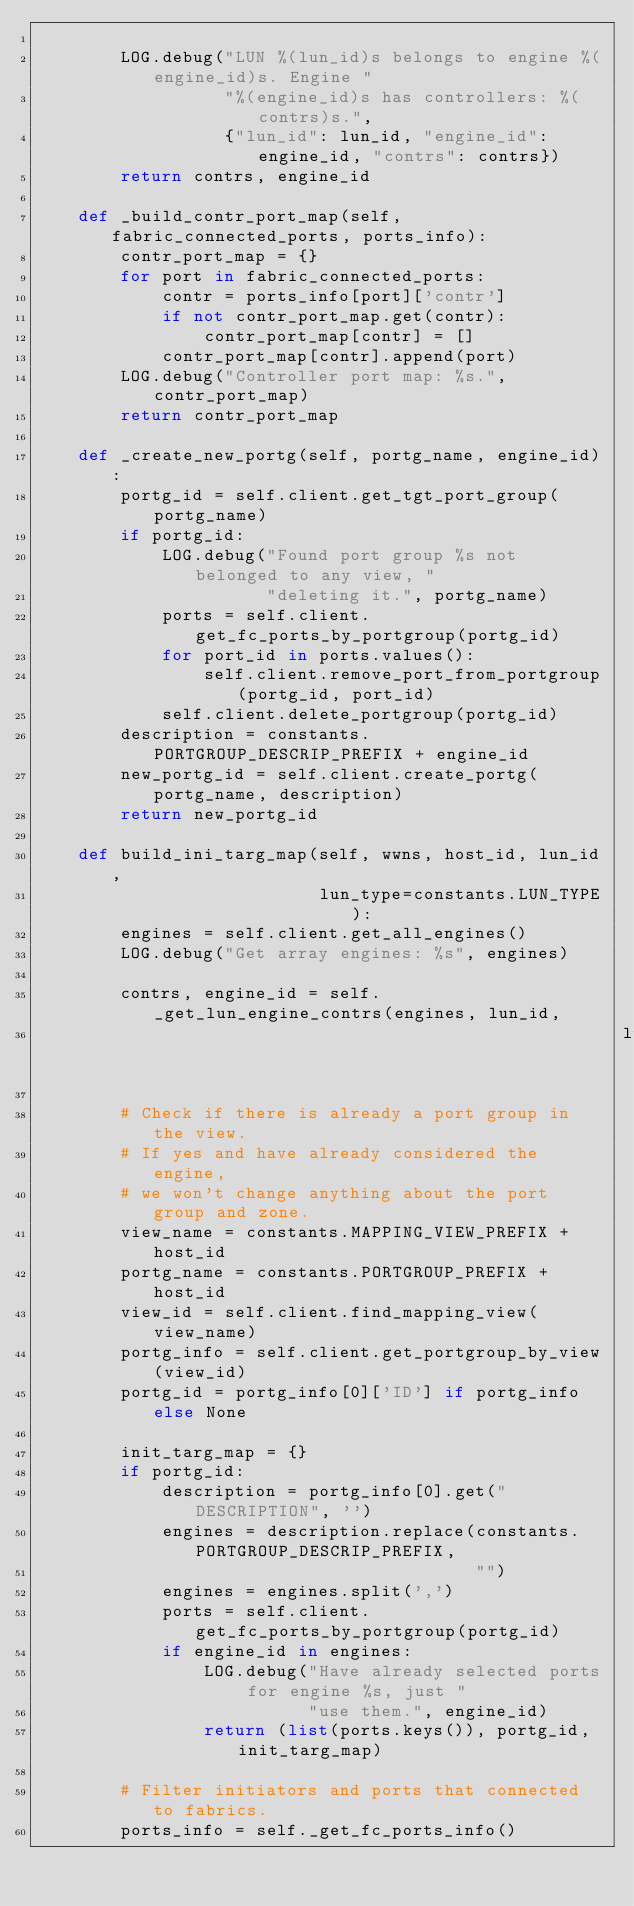Convert code to text. <code><loc_0><loc_0><loc_500><loc_500><_Python_>
        LOG.debug("LUN %(lun_id)s belongs to engine %(engine_id)s. Engine "
                  "%(engine_id)s has controllers: %(contrs)s.",
                  {"lun_id": lun_id, "engine_id": engine_id, "contrs": contrs})
        return contrs, engine_id

    def _build_contr_port_map(self, fabric_connected_ports, ports_info):
        contr_port_map = {}
        for port in fabric_connected_ports:
            contr = ports_info[port]['contr']
            if not contr_port_map.get(contr):
                contr_port_map[contr] = []
            contr_port_map[contr].append(port)
        LOG.debug("Controller port map: %s.", contr_port_map)
        return contr_port_map

    def _create_new_portg(self, portg_name, engine_id):
        portg_id = self.client.get_tgt_port_group(portg_name)
        if portg_id:
            LOG.debug("Found port group %s not belonged to any view, "
                      "deleting it.", portg_name)
            ports = self.client.get_fc_ports_by_portgroup(portg_id)
            for port_id in ports.values():
                self.client.remove_port_from_portgroup(portg_id, port_id)
            self.client.delete_portgroup(portg_id)
        description = constants.PORTGROUP_DESCRIP_PREFIX + engine_id
        new_portg_id = self.client.create_portg(portg_name, description)
        return new_portg_id

    def build_ini_targ_map(self, wwns, host_id, lun_id,
                           lun_type=constants.LUN_TYPE):
        engines = self.client.get_all_engines()
        LOG.debug("Get array engines: %s", engines)

        contrs, engine_id = self._get_lun_engine_contrs(engines, lun_id,
                                                        lun_type)

        # Check if there is already a port group in the view.
        # If yes and have already considered the engine,
        # we won't change anything about the port group and zone.
        view_name = constants.MAPPING_VIEW_PREFIX + host_id
        portg_name = constants.PORTGROUP_PREFIX + host_id
        view_id = self.client.find_mapping_view(view_name)
        portg_info = self.client.get_portgroup_by_view(view_id)
        portg_id = portg_info[0]['ID'] if portg_info else None

        init_targ_map = {}
        if portg_id:
            description = portg_info[0].get("DESCRIPTION", '')
            engines = description.replace(constants.PORTGROUP_DESCRIP_PREFIX,
                                          "")
            engines = engines.split(',')
            ports = self.client.get_fc_ports_by_portgroup(portg_id)
            if engine_id in engines:
                LOG.debug("Have already selected ports for engine %s, just "
                          "use them.", engine_id)
                return (list(ports.keys()), portg_id, init_targ_map)

        # Filter initiators and ports that connected to fabrics.
        ports_info = self._get_fc_ports_info()</code> 